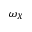Convert formula to latex. <formula><loc_0><loc_0><loc_500><loc_500>\omega _ { X }</formula> 